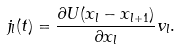<formula> <loc_0><loc_0><loc_500><loc_500>j _ { l } ( t ) = \frac { \partial U ( x _ { l } - x _ { l + 1 } ) } { \partial x _ { l } } v _ { l } .</formula> 